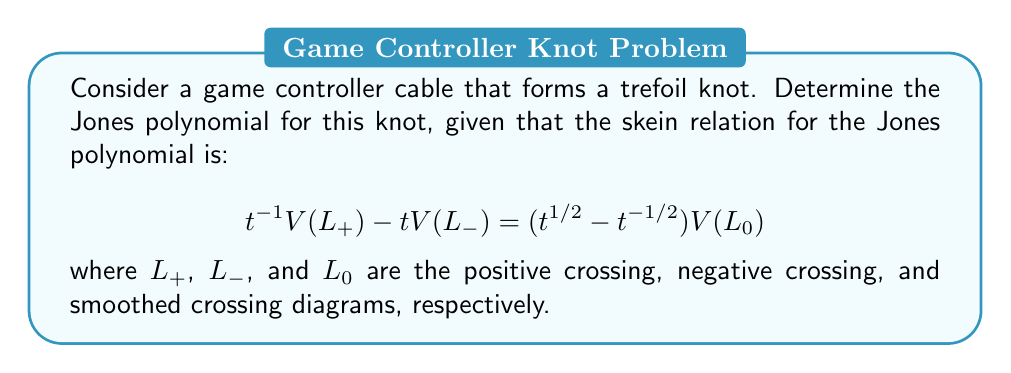Teach me how to tackle this problem. Let's approach this step-by-step:

1) First, recall that the trefoil knot has three positive crossings.

2) We'll use the fact that the Jones polynomial of an unknot is 1:
   $V(\text{unknot}) = 1$

3) Apply the skein relation to one of the crossings:
   $$t^{-1}V(\text{trefoil}) - tV(\text{unknot}) = (t^{1/2} - t^{-1/2})V(\text{Hopf link})$$

4) We know $V(\text{unknot}) = 1$, so:
   $$t^{-1}V(\text{trefoil}) - t = (t^{1/2} - t^{-1/2})V(\text{Hopf link})$$

5) Now we need to find $V(\text{Hopf link})$. Apply the skein relation again:
   $$t^{-1}V(\text{Hopf link}) - tV(\text{unlink}) = (t^{1/2} - t^{-1/2})V(\text{unknot})$$

6) We know $V(\text{unlink}) = -t^{1/2} - t^{-3/2}$ and $V(\text{unknot}) = 1$, so:
   $$t^{-1}V(\text{Hopf link}) + t(-t^{1/2} - t^{-3/2}) = t^{1/2} - t^{-1/2}$$

7) Solve for $V(\text{Hopf link})$:
   $$V(\text{Hopf link}) = -t^{5/2} - t^{1/2}$$

8) Substitute this back into the equation from step 4:
   $$t^{-1}V(\text{trefoil}) - t = (t^{1/2} - t^{-1/2})(-t^{5/2} - t^{1/2})$$

9) Simplify:
   $$t^{-1}V(\text{trefoil}) - t = -t^3 - t - t + t^{-1}$$
   $$t^{-1}V(\text{trefoil}) = -t^3 - 2t + t^{-1} + t$$
   $$V(\text{trefoil}) = -t^4 - t^2 + t + t^2$$

10) Final simplification:
    $$V(\text{trefoil}) = -t^4 + t^2 + t$$
Answer: $-t^4 + t^2 + t$ 